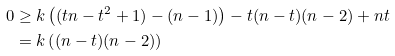<formula> <loc_0><loc_0><loc_500><loc_500>0 & \geq k \left ( ( t n - t ^ { 2 } + 1 ) - ( n - 1 ) \right ) - t ( n - t ) ( n - 2 ) + n t \\ & = k \left ( ( n - t ) ( n - 2 ) \right )</formula> 